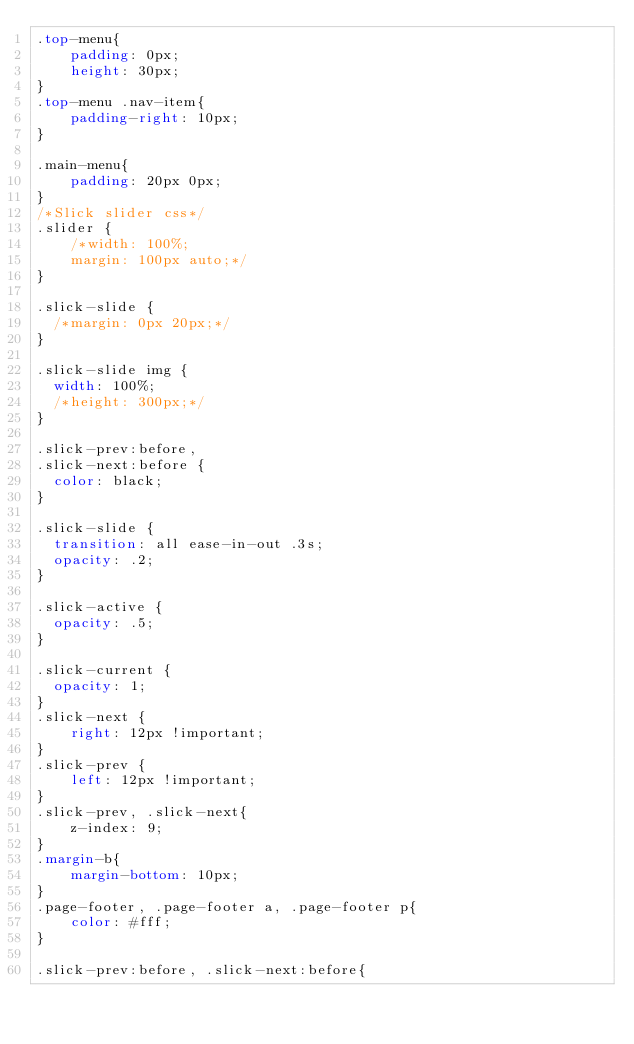Convert code to text. <code><loc_0><loc_0><loc_500><loc_500><_CSS_>.top-menu{
	padding: 0px;
	height: 30px;
}
.top-menu .nav-item{
	padding-right: 10px;
}

.main-menu{
	padding: 20px 0px;
}
/*Slick slider css*/
.slider {
    /*width: 100%;
    margin: 100px auto;*/
}

.slick-slide {
  /*margin: 0px 20px;*/
}

.slick-slide img {
  width: 100%;
  /*height: 300px;*/
}

.slick-prev:before,
.slick-next:before {
  color: black;
}

.slick-slide {
  transition: all ease-in-out .3s;
  opacity: .2;
}

.slick-active {
  opacity: .5;
}

.slick-current {
  opacity: 1;
}
.slick-next {
    right: 12px !important;
}
.slick-prev {
    left: 12px !important;
}
.slick-prev, .slick-next{
	z-index: 9;
}
.margin-b{
    margin-bottom: 10px;
}
.page-footer, .page-footer a, .page-footer p{
    color: #fff;
}

.slick-prev:before, .slick-next:before{</code> 